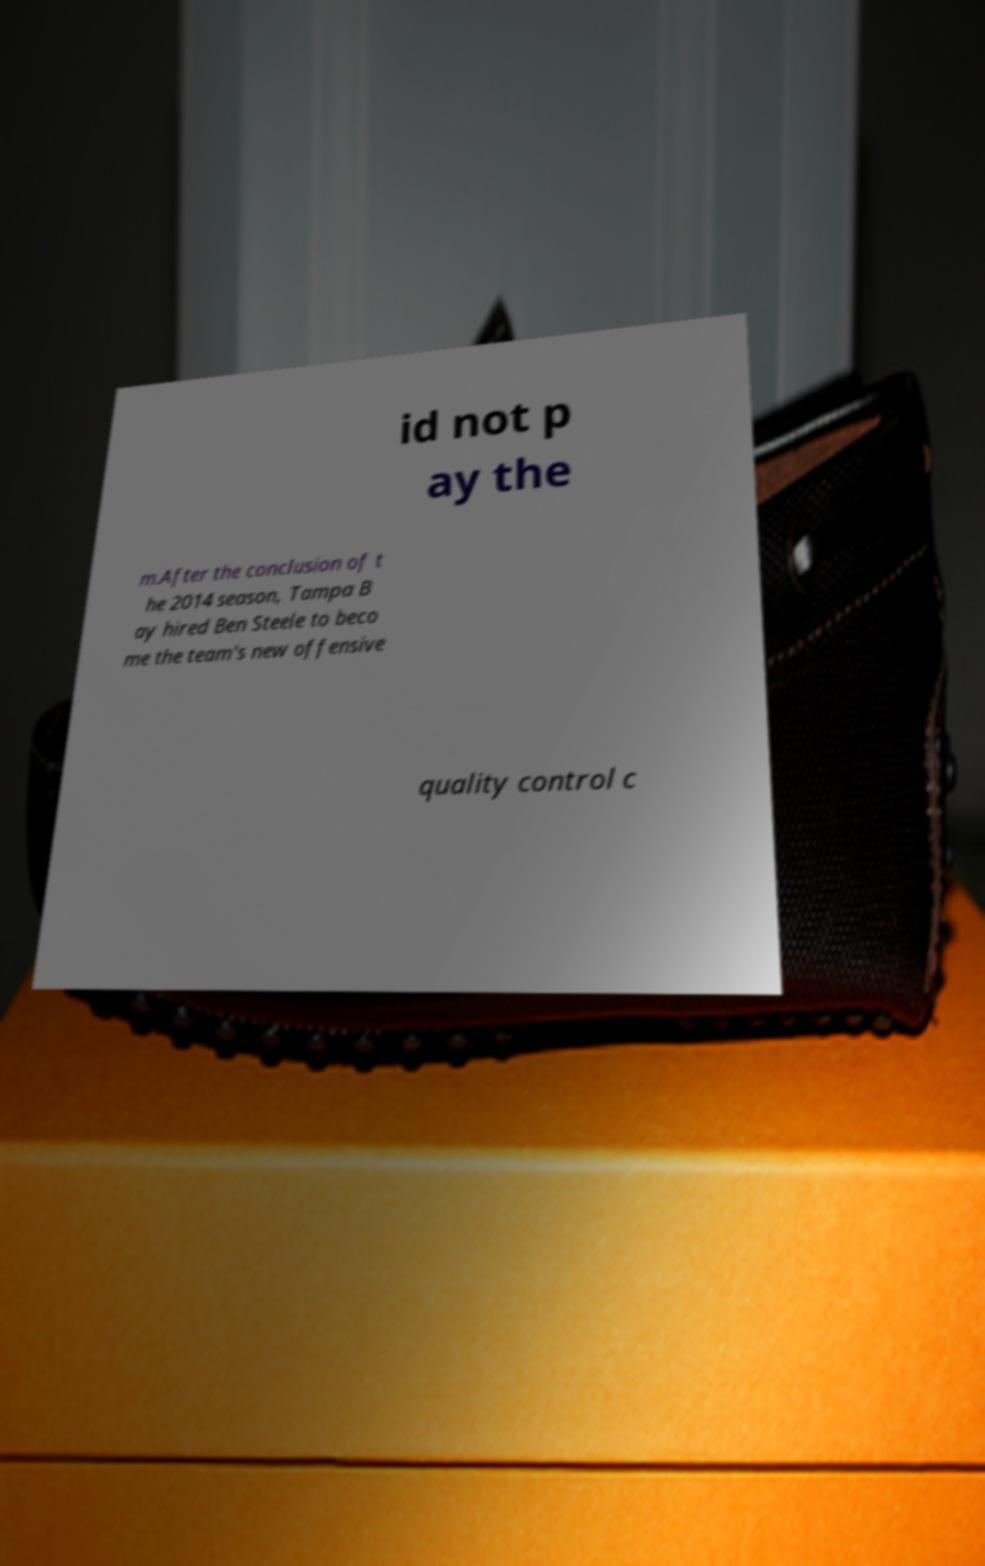Please identify and transcribe the text found in this image. id not p ay the m.After the conclusion of t he 2014 season, Tampa B ay hired Ben Steele to beco me the team's new offensive quality control c 